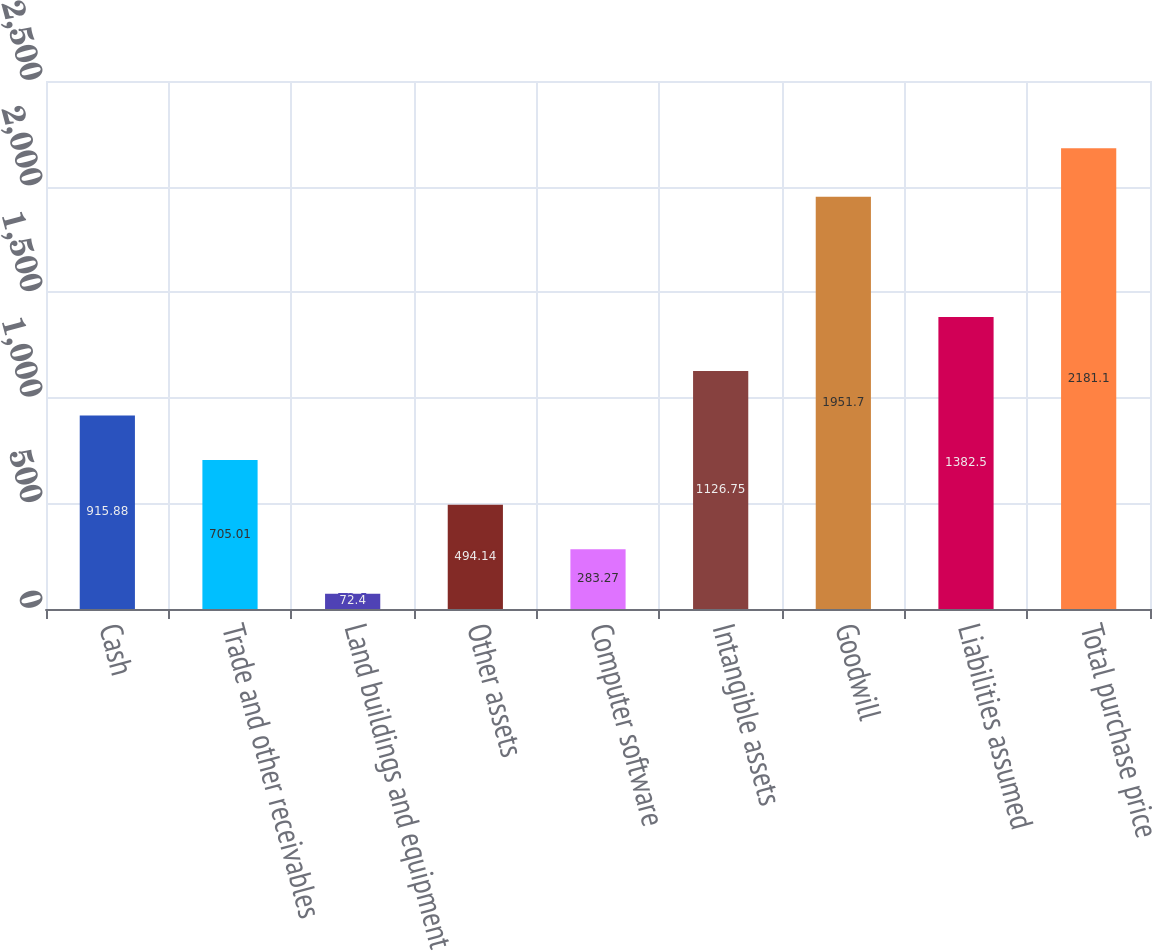Convert chart. <chart><loc_0><loc_0><loc_500><loc_500><bar_chart><fcel>Cash<fcel>Trade and other receivables<fcel>Land buildings and equipment<fcel>Other assets<fcel>Computer software<fcel>Intangible assets<fcel>Goodwill<fcel>Liabilities assumed<fcel>Total purchase price<nl><fcel>915.88<fcel>705.01<fcel>72.4<fcel>494.14<fcel>283.27<fcel>1126.75<fcel>1951.7<fcel>1382.5<fcel>2181.1<nl></chart> 